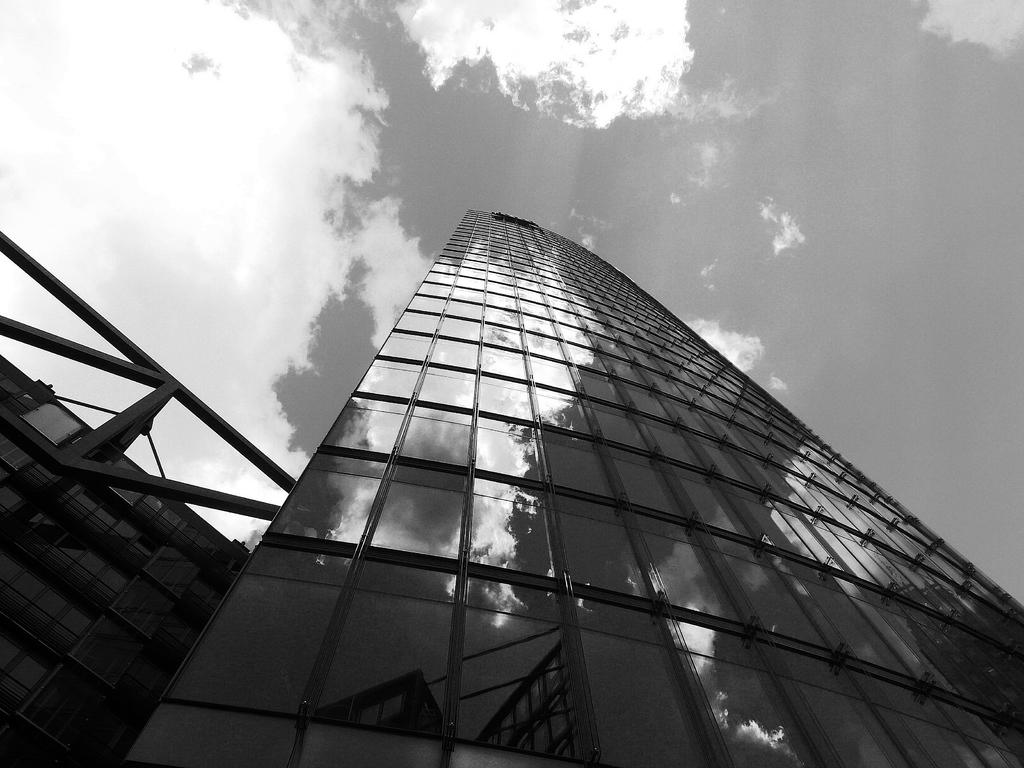What structures are located in the front of the image? There are buildings in the front of the image. What can be seen in the background of the image? There are clouds and the sky visible in the background of the image. What is the color scheme of the image? The image is black and white in color. Can you see any clovers growing in the image? There are no clovers present in the image. How much money is visible in the image? There is no money present in the image. 